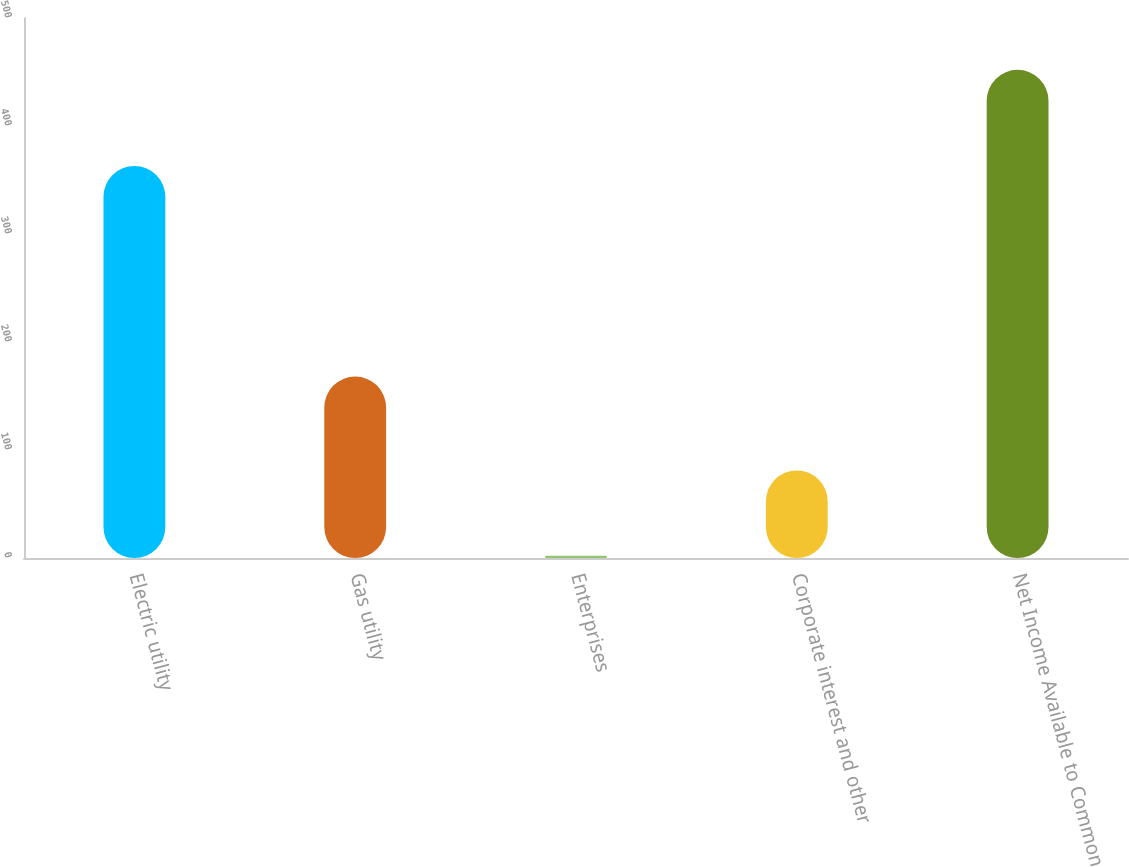Convert chart. <chart><loc_0><loc_0><loc_500><loc_500><bar_chart><fcel>Electric utility<fcel>Gas utility<fcel>Enterprises<fcel>Corporate interest and other<fcel>Net Income Available to Common<nl><fcel>363<fcel>168<fcel>2<fcel>81<fcel>452<nl></chart> 